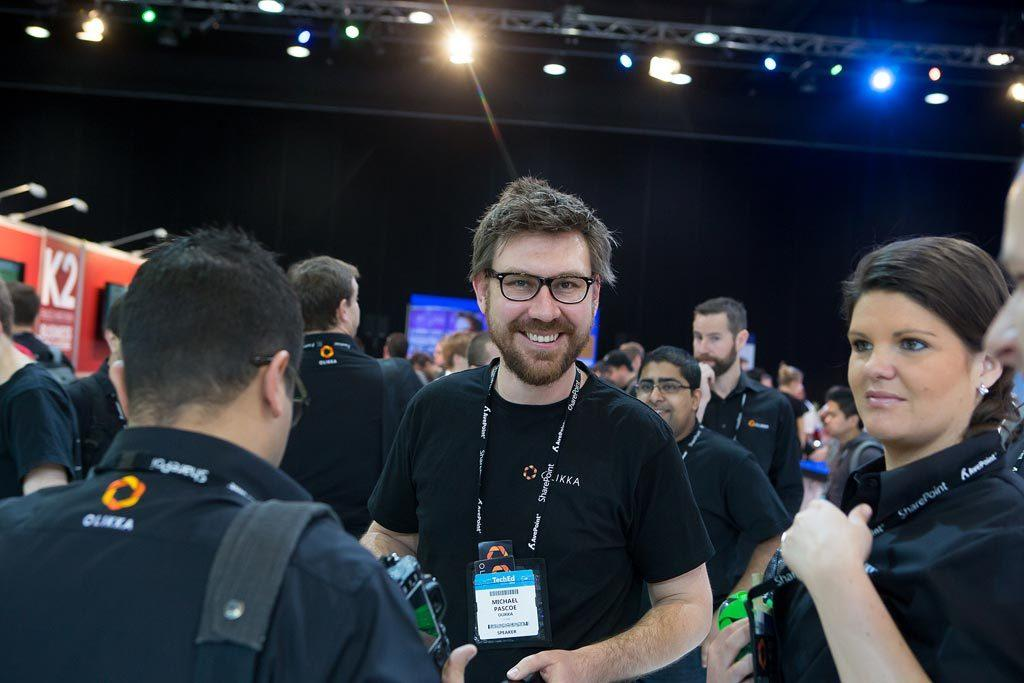What can be seen in the image involving people? There are people standing in the image. What is visible at the top of the image? There are lights visible at the top of the image. What is located on the left side of the image? There is a board on the left side of the image. What is written or displayed on the board? There is text on the board. What type of slope can be seen in the image? There is no slope present in the image. How many forks are visible in the image? There are no forks visible in the image. 